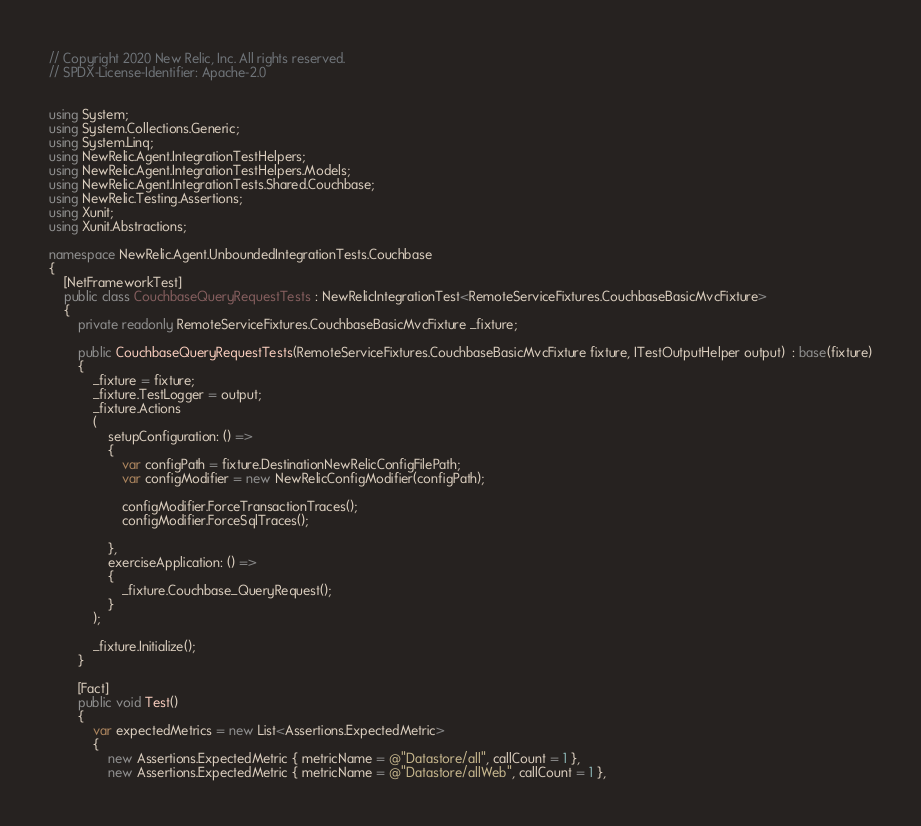<code> <loc_0><loc_0><loc_500><loc_500><_C#_>// Copyright 2020 New Relic, Inc. All rights reserved.
// SPDX-License-Identifier: Apache-2.0


using System;
using System.Collections.Generic;
using System.Linq;
using NewRelic.Agent.IntegrationTestHelpers;
using NewRelic.Agent.IntegrationTestHelpers.Models;
using NewRelic.Agent.IntegrationTests.Shared.Couchbase;
using NewRelic.Testing.Assertions;
using Xunit;
using Xunit.Abstractions;

namespace NewRelic.Agent.UnboundedIntegrationTests.Couchbase
{
    [NetFrameworkTest]
    public class CouchbaseQueryRequestTests : NewRelicIntegrationTest<RemoteServiceFixtures.CouchbaseBasicMvcFixture>
    {
        private readonly RemoteServiceFixtures.CouchbaseBasicMvcFixture _fixture;

        public CouchbaseQueryRequestTests(RemoteServiceFixtures.CouchbaseBasicMvcFixture fixture, ITestOutputHelper output)  : base(fixture)
        {
            _fixture = fixture;
            _fixture.TestLogger = output;
            _fixture.Actions
            (
                setupConfiguration: () =>
                {
                    var configPath = fixture.DestinationNewRelicConfigFilePath;
                    var configModifier = new NewRelicConfigModifier(configPath);

                    configModifier.ForceTransactionTraces();
                    configModifier.ForceSqlTraces();

                },
                exerciseApplication: () =>
                {
                    _fixture.Couchbase_QueryRequest();
                }
            );

            _fixture.Initialize();
        }

        [Fact]
        public void Test()
        {
            var expectedMetrics = new List<Assertions.ExpectedMetric>
            {
                new Assertions.ExpectedMetric { metricName = @"Datastore/all", callCount = 1 },
                new Assertions.ExpectedMetric { metricName = @"Datastore/allWeb", callCount = 1 },</code> 